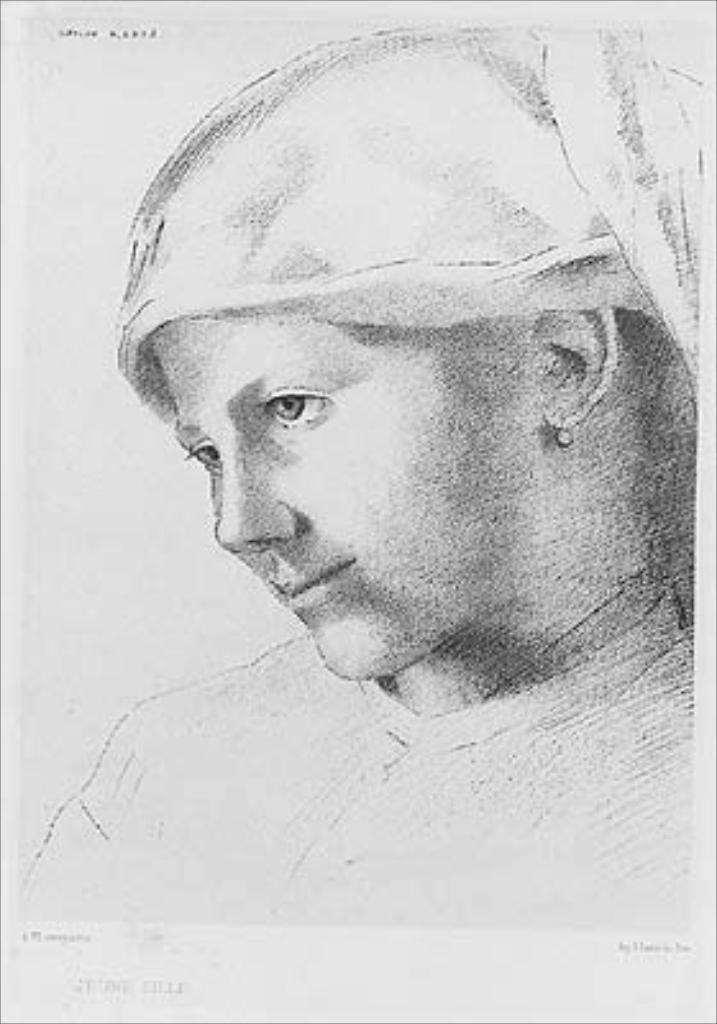What is the main subject of the image? The main subject of the image is a sketch of a woman. What is the woman wearing on her head? The woman is wearing a headgear. What color scheme is used in the image? The image is black and white. What type of popcorn can be seen in the woman's hand in the image? There is no popcorn present in the image; it is a sketch of a woman wearing a headgear. Can you describe the yoke that the woman is using to carry a load in the image? There is no yoke or any indication of carrying a load in the image; it is a sketch of a woman wearing a headgear. 